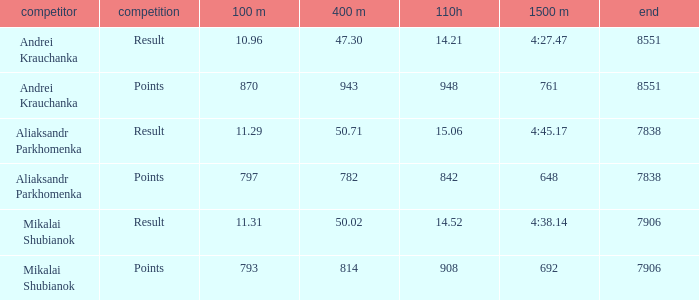What was the 110H that the 1500m was 692 and the final was more than 7906? 0.0. 